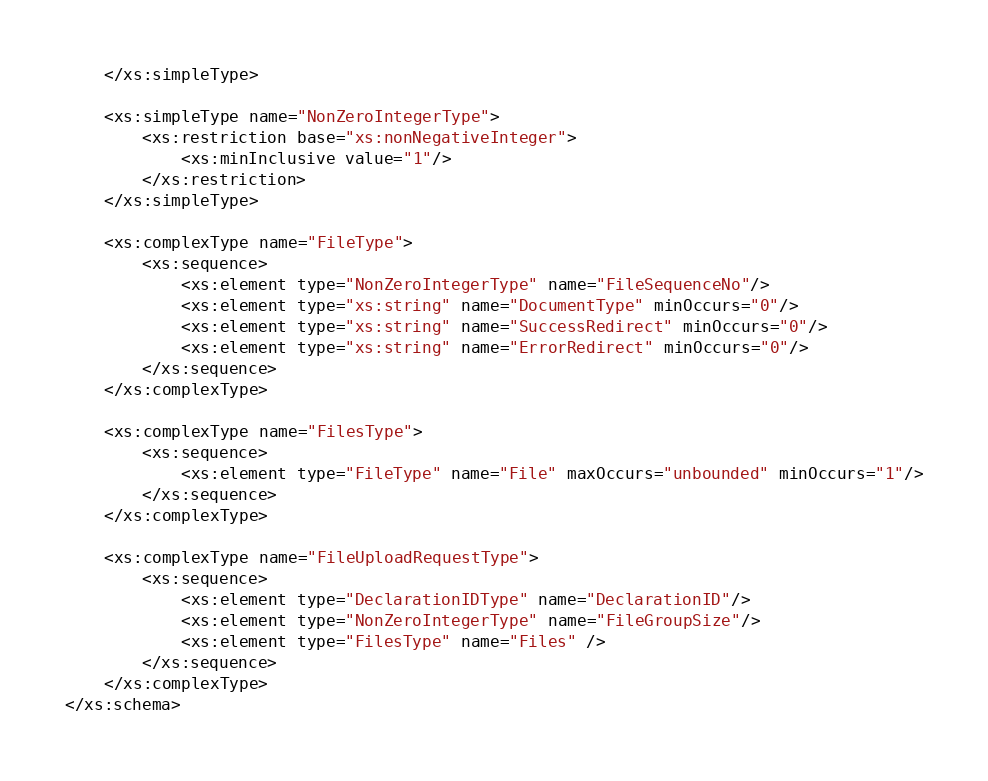Convert code to text. <code><loc_0><loc_0><loc_500><loc_500><_XML_>    </xs:simpleType>

    <xs:simpleType name="NonZeroIntegerType">
        <xs:restriction base="xs:nonNegativeInteger">
            <xs:minInclusive value="1"/>
        </xs:restriction>
    </xs:simpleType>

    <xs:complexType name="FileType">
        <xs:sequence>
            <xs:element type="NonZeroIntegerType" name="FileSequenceNo"/>
            <xs:element type="xs:string" name="DocumentType" minOccurs="0"/>
            <xs:element type="xs:string" name="SuccessRedirect" minOccurs="0"/>
            <xs:element type="xs:string" name="ErrorRedirect" minOccurs="0"/>
        </xs:sequence>
    </xs:complexType>

    <xs:complexType name="FilesType">
        <xs:sequence>
            <xs:element type="FileType" name="File" maxOccurs="unbounded" minOccurs="1"/>
        </xs:sequence>
    </xs:complexType>

    <xs:complexType name="FileUploadRequestType">
        <xs:sequence>
            <xs:element type="DeclarationIDType" name="DeclarationID"/>
            <xs:element type="NonZeroIntegerType" name="FileGroupSize"/>
            <xs:element type="FilesType" name="Files" />
        </xs:sequence>
    </xs:complexType>
</xs:schema>
</code> 